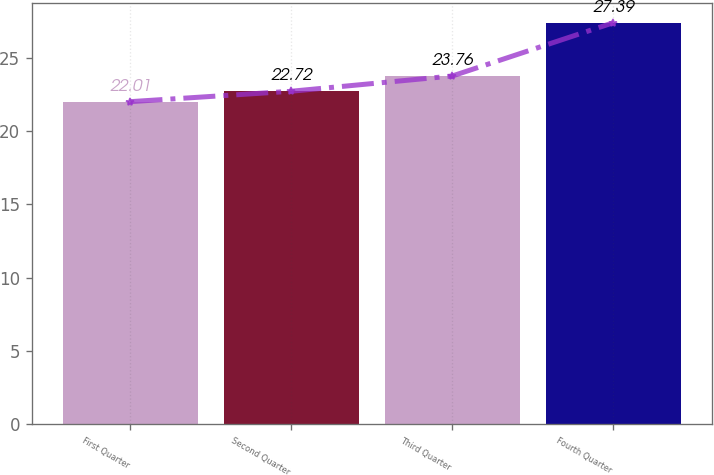<chart> <loc_0><loc_0><loc_500><loc_500><bar_chart><fcel>First Quarter<fcel>Second Quarter<fcel>Third Quarter<fcel>Fourth Quarter<nl><fcel>22.01<fcel>22.72<fcel>23.76<fcel>27.39<nl></chart> 